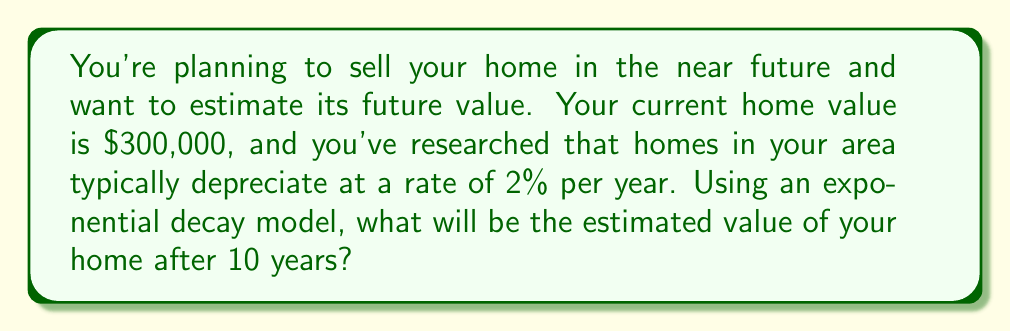Teach me how to tackle this problem. To solve this problem, we'll use the exponential decay model:

$$A(t) = A_0 \cdot e^{-rt}$$

Where:
$A(t)$ is the value after time $t$
$A_0$ is the initial value
$r$ is the decay rate
$t$ is the time in years

Given:
$A_0 = \$300,000$
$r = 0.02$ (2% per year)
$t = 10$ years

Let's substitute these values into the formula:

$$A(10) = 300,000 \cdot e^{-0.02 \cdot 10}$$

Now, let's calculate:

1) First, simplify the exponent:
   $-0.02 \cdot 10 = -0.2$

2) Calculate $e^{-0.2}$:
   $e^{-0.2} \approx 0.8187$

3) Multiply by the initial value:
   $300,000 \cdot 0.8187 \approx 245,610$

Therefore, after 10 years, the estimated value of your home will be approximately $245,610.
Answer: $245,610 